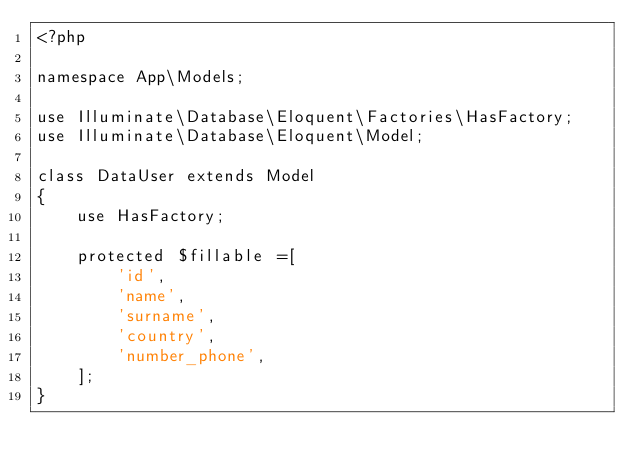Convert code to text. <code><loc_0><loc_0><loc_500><loc_500><_PHP_><?php

namespace App\Models;

use Illuminate\Database\Eloquent\Factories\HasFactory;
use Illuminate\Database\Eloquent\Model;

class DataUser extends Model
{
    use HasFactory;

    protected $fillable =[
        'id',
        'name',
        'surname',
        'country',
        'number_phone',
    ];
}
</code> 